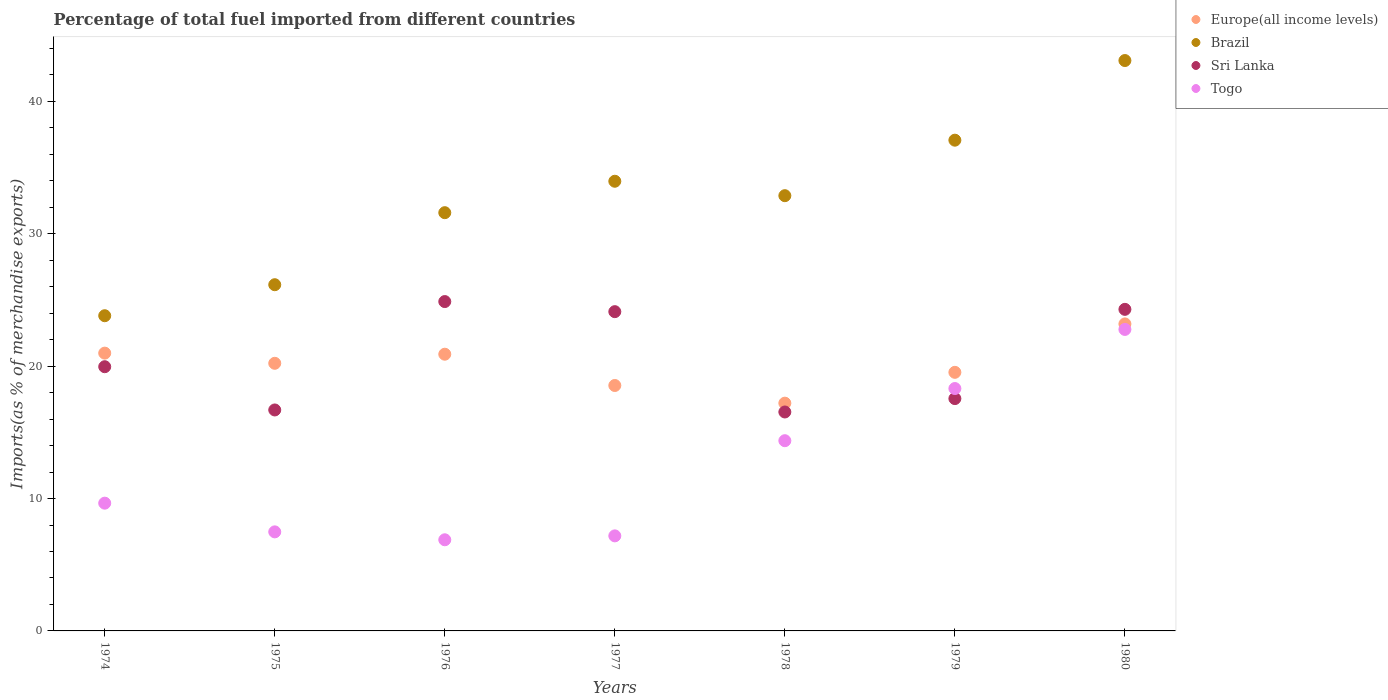What is the percentage of imports to different countries in Togo in 1976?
Offer a very short reply. 6.88. Across all years, what is the maximum percentage of imports to different countries in Sri Lanka?
Offer a terse response. 24.88. Across all years, what is the minimum percentage of imports to different countries in Europe(all income levels)?
Offer a very short reply. 17.2. In which year was the percentage of imports to different countries in Togo minimum?
Keep it short and to the point. 1976. What is the total percentage of imports to different countries in Togo in the graph?
Give a very brief answer. 86.65. What is the difference between the percentage of imports to different countries in Europe(all income levels) in 1978 and that in 1979?
Your response must be concise. -2.33. What is the difference between the percentage of imports to different countries in Sri Lanka in 1975 and the percentage of imports to different countries in Europe(all income levels) in 1977?
Your response must be concise. -1.85. What is the average percentage of imports to different countries in Togo per year?
Your response must be concise. 12.38. In the year 1975, what is the difference between the percentage of imports to different countries in Togo and percentage of imports to different countries in Sri Lanka?
Provide a succinct answer. -9.21. In how many years, is the percentage of imports to different countries in Togo greater than 20 %?
Make the answer very short. 1. What is the ratio of the percentage of imports to different countries in Brazil in 1974 to that in 1978?
Offer a terse response. 0.72. Is the percentage of imports to different countries in Europe(all income levels) in 1978 less than that in 1979?
Your answer should be very brief. Yes. What is the difference between the highest and the second highest percentage of imports to different countries in Europe(all income levels)?
Make the answer very short. 2.21. What is the difference between the highest and the lowest percentage of imports to different countries in Europe(all income levels)?
Offer a terse response. 5.98. In how many years, is the percentage of imports to different countries in Brazil greater than the average percentage of imports to different countries in Brazil taken over all years?
Your response must be concise. 4. Is it the case that in every year, the sum of the percentage of imports to different countries in Europe(all income levels) and percentage of imports to different countries in Sri Lanka  is greater than the percentage of imports to different countries in Brazil?
Keep it short and to the point. Yes. Does the percentage of imports to different countries in Brazil monotonically increase over the years?
Your response must be concise. No. Is the percentage of imports to different countries in Togo strictly greater than the percentage of imports to different countries in Sri Lanka over the years?
Provide a succinct answer. No. Is the percentage of imports to different countries in Europe(all income levels) strictly less than the percentage of imports to different countries in Brazil over the years?
Keep it short and to the point. Yes. Does the graph contain grids?
Offer a terse response. No. How many legend labels are there?
Provide a short and direct response. 4. What is the title of the graph?
Your response must be concise. Percentage of total fuel imported from different countries. Does "Mexico" appear as one of the legend labels in the graph?
Offer a very short reply. No. What is the label or title of the X-axis?
Your answer should be compact. Years. What is the label or title of the Y-axis?
Your answer should be compact. Imports(as % of merchandise exports). What is the Imports(as % of merchandise exports) of Europe(all income levels) in 1974?
Make the answer very short. 20.98. What is the Imports(as % of merchandise exports) in Brazil in 1974?
Give a very brief answer. 23.81. What is the Imports(as % of merchandise exports) in Sri Lanka in 1974?
Provide a short and direct response. 19.96. What is the Imports(as % of merchandise exports) of Togo in 1974?
Your response must be concise. 9.65. What is the Imports(as % of merchandise exports) in Europe(all income levels) in 1975?
Ensure brevity in your answer.  20.22. What is the Imports(as % of merchandise exports) of Brazil in 1975?
Your answer should be compact. 26.15. What is the Imports(as % of merchandise exports) in Sri Lanka in 1975?
Keep it short and to the point. 16.69. What is the Imports(as % of merchandise exports) in Togo in 1975?
Your response must be concise. 7.48. What is the Imports(as % of merchandise exports) of Europe(all income levels) in 1976?
Provide a short and direct response. 20.9. What is the Imports(as % of merchandise exports) of Brazil in 1976?
Offer a very short reply. 31.59. What is the Imports(as % of merchandise exports) in Sri Lanka in 1976?
Your answer should be compact. 24.88. What is the Imports(as % of merchandise exports) in Togo in 1976?
Provide a succinct answer. 6.88. What is the Imports(as % of merchandise exports) in Europe(all income levels) in 1977?
Offer a terse response. 18.54. What is the Imports(as % of merchandise exports) in Brazil in 1977?
Offer a terse response. 33.97. What is the Imports(as % of merchandise exports) of Sri Lanka in 1977?
Give a very brief answer. 24.12. What is the Imports(as % of merchandise exports) in Togo in 1977?
Offer a very short reply. 7.18. What is the Imports(as % of merchandise exports) of Europe(all income levels) in 1978?
Your answer should be very brief. 17.2. What is the Imports(as % of merchandise exports) in Brazil in 1978?
Give a very brief answer. 32.88. What is the Imports(as % of merchandise exports) in Sri Lanka in 1978?
Your answer should be very brief. 16.54. What is the Imports(as % of merchandise exports) in Togo in 1978?
Offer a terse response. 14.37. What is the Imports(as % of merchandise exports) in Europe(all income levels) in 1979?
Offer a terse response. 19.53. What is the Imports(as % of merchandise exports) of Brazil in 1979?
Ensure brevity in your answer.  37.07. What is the Imports(as % of merchandise exports) of Sri Lanka in 1979?
Make the answer very short. 17.55. What is the Imports(as % of merchandise exports) in Togo in 1979?
Give a very brief answer. 18.31. What is the Imports(as % of merchandise exports) of Europe(all income levels) in 1980?
Provide a short and direct response. 23.19. What is the Imports(as % of merchandise exports) in Brazil in 1980?
Offer a terse response. 43.08. What is the Imports(as % of merchandise exports) in Sri Lanka in 1980?
Provide a short and direct response. 24.29. What is the Imports(as % of merchandise exports) of Togo in 1980?
Offer a terse response. 22.77. Across all years, what is the maximum Imports(as % of merchandise exports) in Europe(all income levels)?
Provide a succinct answer. 23.19. Across all years, what is the maximum Imports(as % of merchandise exports) of Brazil?
Provide a short and direct response. 43.08. Across all years, what is the maximum Imports(as % of merchandise exports) in Sri Lanka?
Offer a terse response. 24.88. Across all years, what is the maximum Imports(as % of merchandise exports) in Togo?
Ensure brevity in your answer.  22.77. Across all years, what is the minimum Imports(as % of merchandise exports) in Europe(all income levels)?
Provide a succinct answer. 17.2. Across all years, what is the minimum Imports(as % of merchandise exports) in Brazil?
Make the answer very short. 23.81. Across all years, what is the minimum Imports(as % of merchandise exports) in Sri Lanka?
Make the answer very short. 16.54. Across all years, what is the minimum Imports(as % of merchandise exports) of Togo?
Offer a terse response. 6.88. What is the total Imports(as % of merchandise exports) of Europe(all income levels) in the graph?
Ensure brevity in your answer.  140.57. What is the total Imports(as % of merchandise exports) of Brazil in the graph?
Provide a succinct answer. 228.55. What is the total Imports(as % of merchandise exports) in Sri Lanka in the graph?
Give a very brief answer. 144.02. What is the total Imports(as % of merchandise exports) in Togo in the graph?
Ensure brevity in your answer.  86.65. What is the difference between the Imports(as % of merchandise exports) of Europe(all income levels) in 1974 and that in 1975?
Provide a short and direct response. 0.77. What is the difference between the Imports(as % of merchandise exports) in Brazil in 1974 and that in 1975?
Provide a succinct answer. -2.34. What is the difference between the Imports(as % of merchandise exports) of Sri Lanka in 1974 and that in 1975?
Give a very brief answer. 3.27. What is the difference between the Imports(as % of merchandise exports) in Togo in 1974 and that in 1975?
Offer a very short reply. 2.17. What is the difference between the Imports(as % of merchandise exports) in Europe(all income levels) in 1974 and that in 1976?
Ensure brevity in your answer.  0.08. What is the difference between the Imports(as % of merchandise exports) of Brazil in 1974 and that in 1976?
Give a very brief answer. -7.78. What is the difference between the Imports(as % of merchandise exports) in Sri Lanka in 1974 and that in 1976?
Make the answer very short. -4.92. What is the difference between the Imports(as % of merchandise exports) in Togo in 1974 and that in 1976?
Offer a very short reply. 2.77. What is the difference between the Imports(as % of merchandise exports) in Europe(all income levels) in 1974 and that in 1977?
Make the answer very short. 2.44. What is the difference between the Imports(as % of merchandise exports) of Brazil in 1974 and that in 1977?
Give a very brief answer. -10.16. What is the difference between the Imports(as % of merchandise exports) of Sri Lanka in 1974 and that in 1977?
Your answer should be compact. -4.16. What is the difference between the Imports(as % of merchandise exports) of Togo in 1974 and that in 1977?
Give a very brief answer. 2.47. What is the difference between the Imports(as % of merchandise exports) of Europe(all income levels) in 1974 and that in 1978?
Provide a short and direct response. 3.78. What is the difference between the Imports(as % of merchandise exports) of Brazil in 1974 and that in 1978?
Your answer should be compact. -9.07. What is the difference between the Imports(as % of merchandise exports) of Sri Lanka in 1974 and that in 1978?
Your response must be concise. 3.42. What is the difference between the Imports(as % of merchandise exports) in Togo in 1974 and that in 1978?
Provide a succinct answer. -4.72. What is the difference between the Imports(as % of merchandise exports) of Europe(all income levels) in 1974 and that in 1979?
Your response must be concise. 1.45. What is the difference between the Imports(as % of merchandise exports) in Brazil in 1974 and that in 1979?
Your answer should be very brief. -13.26. What is the difference between the Imports(as % of merchandise exports) of Sri Lanka in 1974 and that in 1979?
Keep it short and to the point. 2.41. What is the difference between the Imports(as % of merchandise exports) in Togo in 1974 and that in 1979?
Keep it short and to the point. -8.66. What is the difference between the Imports(as % of merchandise exports) in Europe(all income levels) in 1974 and that in 1980?
Make the answer very short. -2.21. What is the difference between the Imports(as % of merchandise exports) in Brazil in 1974 and that in 1980?
Offer a very short reply. -19.28. What is the difference between the Imports(as % of merchandise exports) in Sri Lanka in 1974 and that in 1980?
Provide a succinct answer. -4.33. What is the difference between the Imports(as % of merchandise exports) of Togo in 1974 and that in 1980?
Your answer should be compact. -13.12. What is the difference between the Imports(as % of merchandise exports) in Europe(all income levels) in 1975 and that in 1976?
Provide a succinct answer. -0.69. What is the difference between the Imports(as % of merchandise exports) of Brazil in 1975 and that in 1976?
Ensure brevity in your answer.  -5.44. What is the difference between the Imports(as % of merchandise exports) in Sri Lanka in 1975 and that in 1976?
Provide a short and direct response. -8.19. What is the difference between the Imports(as % of merchandise exports) in Togo in 1975 and that in 1976?
Keep it short and to the point. 0.6. What is the difference between the Imports(as % of merchandise exports) of Europe(all income levels) in 1975 and that in 1977?
Your answer should be compact. 1.68. What is the difference between the Imports(as % of merchandise exports) of Brazil in 1975 and that in 1977?
Provide a succinct answer. -7.82. What is the difference between the Imports(as % of merchandise exports) in Sri Lanka in 1975 and that in 1977?
Provide a short and direct response. -7.43. What is the difference between the Imports(as % of merchandise exports) of Togo in 1975 and that in 1977?
Your answer should be very brief. 0.3. What is the difference between the Imports(as % of merchandise exports) of Europe(all income levels) in 1975 and that in 1978?
Make the answer very short. 3.01. What is the difference between the Imports(as % of merchandise exports) in Brazil in 1975 and that in 1978?
Your response must be concise. -6.73. What is the difference between the Imports(as % of merchandise exports) in Sri Lanka in 1975 and that in 1978?
Offer a terse response. 0.15. What is the difference between the Imports(as % of merchandise exports) of Togo in 1975 and that in 1978?
Your answer should be very brief. -6.89. What is the difference between the Imports(as % of merchandise exports) in Europe(all income levels) in 1975 and that in 1979?
Keep it short and to the point. 0.68. What is the difference between the Imports(as % of merchandise exports) in Brazil in 1975 and that in 1979?
Your answer should be compact. -10.92. What is the difference between the Imports(as % of merchandise exports) in Sri Lanka in 1975 and that in 1979?
Ensure brevity in your answer.  -0.86. What is the difference between the Imports(as % of merchandise exports) of Togo in 1975 and that in 1979?
Keep it short and to the point. -10.83. What is the difference between the Imports(as % of merchandise exports) in Europe(all income levels) in 1975 and that in 1980?
Make the answer very short. -2.97. What is the difference between the Imports(as % of merchandise exports) in Brazil in 1975 and that in 1980?
Ensure brevity in your answer.  -16.93. What is the difference between the Imports(as % of merchandise exports) of Sri Lanka in 1975 and that in 1980?
Ensure brevity in your answer.  -7.6. What is the difference between the Imports(as % of merchandise exports) of Togo in 1975 and that in 1980?
Your response must be concise. -15.29. What is the difference between the Imports(as % of merchandise exports) in Europe(all income levels) in 1976 and that in 1977?
Your answer should be very brief. 2.36. What is the difference between the Imports(as % of merchandise exports) of Brazil in 1976 and that in 1977?
Make the answer very short. -2.37. What is the difference between the Imports(as % of merchandise exports) in Sri Lanka in 1976 and that in 1977?
Give a very brief answer. 0.76. What is the difference between the Imports(as % of merchandise exports) in Togo in 1976 and that in 1977?
Provide a short and direct response. -0.3. What is the difference between the Imports(as % of merchandise exports) of Europe(all income levels) in 1976 and that in 1978?
Your response must be concise. 3.7. What is the difference between the Imports(as % of merchandise exports) of Brazil in 1976 and that in 1978?
Your answer should be compact. -1.28. What is the difference between the Imports(as % of merchandise exports) in Sri Lanka in 1976 and that in 1978?
Your answer should be very brief. 8.34. What is the difference between the Imports(as % of merchandise exports) in Togo in 1976 and that in 1978?
Your answer should be compact. -7.48. What is the difference between the Imports(as % of merchandise exports) in Europe(all income levels) in 1976 and that in 1979?
Give a very brief answer. 1.37. What is the difference between the Imports(as % of merchandise exports) of Brazil in 1976 and that in 1979?
Your answer should be compact. -5.48. What is the difference between the Imports(as % of merchandise exports) of Sri Lanka in 1976 and that in 1979?
Your response must be concise. 7.33. What is the difference between the Imports(as % of merchandise exports) of Togo in 1976 and that in 1979?
Your response must be concise. -11.42. What is the difference between the Imports(as % of merchandise exports) in Europe(all income levels) in 1976 and that in 1980?
Make the answer very short. -2.29. What is the difference between the Imports(as % of merchandise exports) in Brazil in 1976 and that in 1980?
Your answer should be compact. -11.49. What is the difference between the Imports(as % of merchandise exports) of Sri Lanka in 1976 and that in 1980?
Offer a very short reply. 0.59. What is the difference between the Imports(as % of merchandise exports) of Togo in 1976 and that in 1980?
Provide a succinct answer. -15.89. What is the difference between the Imports(as % of merchandise exports) of Europe(all income levels) in 1977 and that in 1978?
Give a very brief answer. 1.33. What is the difference between the Imports(as % of merchandise exports) in Brazil in 1977 and that in 1978?
Ensure brevity in your answer.  1.09. What is the difference between the Imports(as % of merchandise exports) in Sri Lanka in 1977 and that in 1978?
Provide a short and direct response. 7.58. What is the difference between the Imports(as % of merchandise exports) of Togo in 1977 and that in 1978?
Your answer should be very brief. -7.19. What is the difference between the Imports(as % of merchandise exports) in Europe(all income levels) in 1977 and that in 1979?
Provide a short and direct response. -0.99. What is the difference between the Imports(as % of merchandise exports) of Brazil in 1977 and that in 1979?
Offer a terse response. -3.1. What is the difference between the Imports(as % of merchandise exports) of Sri Lanka in 1977 and that in 1979?
Keep it short and to the point. 6.57. What is the difference between the Imports(as % of merchandise exports) of Togo in 1977 and that in 1979?
Your answer should be compact. -11.13. What is the difference between the Imports(as % of merchandise exports) in Europe(all income levels) in 1977 and that in 1980?
Give a very brief answer. -4.65. What is the difference between the Imports(as % of merchandise exports) in Brazil in 1977 and that in 1980?
Your response must be concise. -9.12. What is the difference between the Imports(as % of merchandise exports) of Sri Lanka in 1977 and that in 1980?
Ensure brevity in your answer.  -0.17. What is the difference between the Imports(as % of merchandise exports) of Togo in 1977 and that in 1980?
Make the answer very short. -15.59. What is the difference between the Imports(as % of merchandise exports) in Europe(all income levels) in 1978 and that in 1979?
Make the answer very short. -2.33. What is the difference between the Imports(as % of merchandise exports) of Brazil in 1978 and that in 1979?
Provide a succinct answer. -4.19. What is the difference between the Imports(as % of merchandise exports) of Sri Lanka in 1978 and that in 1979?
Keep it short and to the point. -1.01. What is the difference between the Imports(as % of merchandise exports) of Togo in 1978 and that in 1979?
Your response must be concise. -3.94. What is the difference between the Imports(as % of merchandise exports) of Europe(all income levels) in 1978 and that in 1980?
Provide a succinct answer. -5.98. What is the difference between the Imports(as % of merchandise exports) in Brazil in 1978 and that in 1980?
Your answer should be very brief. -10.21. What is the difference between the Imports(as % of merchandise exports) in Sri Lanka in 1978 and that in 1980?
Offer a terse response. -7.75. What is the difference between the Imports(as % of merchandise exports) in Togo in 1978 and that in 1980?
Your answer should be very brief. -8.4. What is the difference between the Imports(as % of merchandise exports) in Europe(all income levels) in 1979 and that in 1980?
Make the answer very short. -3.66. What is the difference between the Imports(as % of merchandise exports) in Brazil in 1979 and that in 1980?
Keep it short and to the point. -6.02. What is the difference between the Imports(as % of merchandise exports) of Sri Lanka in 1979 and that in 1980?
Offer a terse response. -6.74. What is the difference between the Imports(as % of merchandise exports) of Togo in 1979 and that in 1980?
Give a very brief answer. -4.46. What is the difference between the Imports(as % of merchandise exports) in Europe(all income levels) in 1974 and the Imports(as % of merchandise exports) in Brazil in 1975?
Keep it short and to the point. -5.17. What is the difference between the Imports(as % of merchandise exports) of Europe(all income levels) in 1974 and the Imports(as % of merchandise exports) of Sri Lanka in 1975?
Your answer should be very brief. 4.29. What is the difference between the Imports(as % of merchandise exports) of Europe(all income levels) in 1974 and the Imports(as % of merchandise exports) of Togo in 1975?
Ensure brevity in your answer.  13.5. What is the difference between the Imports(as % of merchandise exports) of Brazil in 1974 and the Imports(as % of merchandise exports) of Sri Lanka in 1975?
Your answer should be very brief. 7.12. What is the difference between the Imports(as % of merchandise exports) of Brazil in 1974 and the Imports(as % of merchandise exports) of Togo in 1975?
Your answer should be compact. 16.33. What is the difference between the Imports(as % of merchandise exports) in Sri Lanka in 1974 and the Imports(as % of merchandise exports) in Togo in 1975?
Ensure brevity in your answer.  12.48. What is the difference between the Imports(as % of merchandise exports) of Europe(all income levels) in 1974 and the Imports(as % of merchandise exports) of Brazil in 1976?
Offer a terse response. -10.61. What is the difference between the Imports(as % of merchandise exports) in Europe(all income levels) in 1974 and the Imports(as % of merchandise exports) in Sri Lanka in 1976?
Provide a succinct answer. -3.89. What is the difference between the Imports(as % of merchandise exports) of Europe(all income levels) in 1974 and the Imports(as % of merchandise exports) of Togo in 1976?
Offer a very short reply. 14.1. What is the difference between the Imports(as % of merchandise exports) of Brazil in 1974 and the Imports(as % of merchandise exports) of Sri Lanka in 1976?
Make the answer very short. -1.07. What is the difference between the Imports(as % of merchandise exports) of Brazil in 1974 and the Imports(as % of merchandise exports) of Togo in 1976?
Make the answer very short. 16.92. What is the difference between the Imports(as % of merchandise exports) in Sri Lanka in 1974 and the Imports(as % of merchandise exports) in Togo in 1976?
Your response must be concise. 13.07. What is the difference between the Imports(as % of merchandise exports) in Europe(all income levels) in 1974 and the Imports(as % of merchandise exports) in Brazil in 1977?
Your response must be concise. -12.98. What is the difference between the Imports(as % of merchandise exports) of Europe(all income levels) in 1974 and the Imports(as % of merchandise exports) of Sri Lanka in 1977?
Your answer should be very brief. -3.13. What is the difference between the Imports(as % of merchandise exports) in Europe(all income levels) in 1974 and the Imports(as % of merchandise exports) in Togo in 1977?
Your response must be concise. 13.8. What is the difference between the Imports(as % of merchandise exports) in Brazil in 1974 and the Imports(as % of merchandise exports) in Sri Lanka in 1977?
Give a very brief answer. -0.31. What is the difference between the Imports(as % of merchandise exports) in Brazil in 1974 and the Imports(as % of merchandise exports) in Togo in 1977?
Keep it short and to the point. 16.63. What is the difference between the Imports(as % of merchandise exports) in Sri Lanka in 1974 and the Imports(as % of merchandise exports) in Togo in 1977?
Give a very brief answer. 12.78. What is the difference between the Imports(as % of merchandise exports) of Europe(all income levels) in 1974 and the Imports(as % of merchandise exports) of Brazil in 1978?
Give a very brief answer. -11.89. What is the difference between the Imports(as % of merchandise exports) in Europe(all income levels) in 1974 and the Imports(as % of merchandise exports) in Sri Lanka in 1978?
Your answer should be very brief. 4.45. What is the difference between the Imports(as % of merchandise exports) of Europe(all income levels) in 1974 and the Imports(as % of merchandise exports) of Togo in 1978?
Keep it short and to the point. 6.62. What is the difference between the Imports(as % of merchandise exports) in Brazil in 1974 and the Imports(as % of merchandise exports) in Sri Lanka in 1978?
Provide a succinct answer. 7.27. What is the difference between the Imports(as % of merchandise exports) in Brazil in 1974 and the Imports(as % of merchandise exports) in Togo in 1978?
Offer a very short reply. 9.44. What is the difference between the Imports(as % of merchandise exports) in Sri Lanka in 1974 and the Imports(as % of merchandise exports) in Togo in 1978?
Give a very brief answer. 5.59. What is the difference between the Imports(as % of merchandise exports) in Europe(all income levels) in 1974 and the Imports(as % of merchandise exports) in Brazil in 1979?
Offer a terse response. -16.09. What is the difference between the Imports(as % of merchandise exports) of Europe(all income levels) in 1974 and the Imports(as % of merchandise exports) of Sri Lanka in 1979?
Provide a short and direct response. 3.43. What is the difference between the Imports(as % of merchandise exports) in Europe(all income levels) in 1974 and the Imports(as % of merchandise exports) in Togo in 1979?
Your answer should be compact. 2.67. What is the difference between the Imports(as % of merchandise exports) of Brazil in 1974 and the Imports(as % of merchandise exports) of Sri Lanka in 1979?
Offer a terse response. 6.26. What is the difference between the Imports(as % of merchandise exports) in Brazil in 1974 and the Imports(as % of merchandise exports) in Togo in 1979?
Provide a short and direct response. 5.5. What is the difference between the Imports(as % of merchandise exports) of Sri Lanka in 1974 and the Imports(as % of merchandise exports) of Togo in 1979?
Keep it short and to the point. 1.65. What is the difference between the Imports(as % of merchandise exports) in Europe(all income levels) in 1974 and the Imports(as % of merchandise exports) in Brazil in 1980?
Keep it short and to the point. -22.1. What is the difference between the Imports(as % of merchandise exports) of Europe(all income levels) in 1974 and the Imports(as % of merchandise exports) of Sri Lanka in 1980?
Provide a succinct answer. -3.31. What is the difference between the Imports(as % of merchandise exports) of Europe(all income levels) in 1974 and the Imports(as % of merchandise exports) of Togo in 1980?
Keep it short and to the point. -1.79. What is the difference between the Imports(as % of merchandise exports) of Brazil in 1974 and the Imports(as % of merchandise exports) of Sri Lanka in 1980?
Give a very brief answer. -0.48. What is the difference between the Imports(as % of merchandise exports) in Brazil in 1974 and the Imports(as % of merchandise exports) in Togo in 1980?
Offer a terse response. 1.04. What is the difference between the Imports(as % of merchandise exports) of Sri Lanka in 1974 and the Imports(as % of merchandise exports) of Togo in 1980?
Ensure brevity in your answer.  -2.82. What is the difference between the Imports(as % of merchandise exports) of Europe(all income levels) in 1975 and the Imports(as % of merchandise exports) of Brazil in 1976?
Provide a succinct answer. -11.38. What is the difference between the Imports(as % of merchandise exports) of Europe(all income levels) in 1975 and the Imports(as % of merchandise exports) of Sri Lanka in 1976?
Keep it short and to the point. -4.66. What is the difference between the Imports(as % of merchandise exports) of Europe(all income levels) in 1975 and the Imports(as % of merchandise exports) of Togo in 1976?
Your answer should be very brief. 13.33. What is the difference between the Imports(as % of merchandise exports) in Brazil in 1975 and the Imports(as % of merchandise exports) in Sri Lanka in 1976?
Keep it short and to the point. 1.27. What is the difference between the Imports(as % of merchandise exports) of Brazil in 1975 and the Imports(as % of merchandise exports) of Togo in 1976?
Provide a succinct answer. 19.27. What is the difference between the Imports(as % of merchandise exports) in Sri Lanka in 1975 and the Imports(as % of merchandise exports) in Togo in 1976?
Your response must be concise. 9.81. What is the difference between the Imports(as % of merchandise exports) in Europe(all income levels) in 1975 and the Imports(as % of merchandise exports) in Brazil in 1977?
Provide a succinct answer. -13.75. What is the difference between the Imports(as % of merchandise exports) of Europe(all income levels) in 1975 and the Imports(as % of merchandise exports) of Sri Lanka in 1977?
Your answer should be very brief. -3.9. What is the difference between the Imports(as % of merchandise exports) in Europe(all income levels) in 1975 and the Imports(as % of merchandise exports) in Togo in 1977?
Offer a terse response. 13.04. What is the difference between the Imports(as % of merchandise exports) of Brazil in 1975 and the Imports(as % of merchandise exports) of Sri Lanka in 1977?
Offer a terse response. 2.04. What is the difference between the Imports(as % of merchandise exports) in Brazil in 1975 and the Imports(as % of merchandise exports) in Togo in 1977?
Your response must be concise. 18.97. What is the difference between the Imports(as % of merchandise exports) in Sri Lanka in 1975 and the Imports(as % of merchandise exports) in Togo in 1977?
Your response must be concise. 9.51. What is the difference between the Imports(as % of merchandise exports) in Europe(all income levels) in 1975 and the Imports(as % of merchandise exports) in Brazil in 1978?
Provide a short and direct response. -12.66. What is the difference between the Imports(as % of merchandise exports) in Europe(all income levels) in 1975 and the Imports(as % of merchandise exports) in Sri Lanka in 1978?
Keep it short and to the point. 3.68. What is the difference between the Imports(as % of merchandise exports) in Europe(all income levels) in 1975 and the Imports(as % of merchandise exports) in Togo in 1978?
Your answer should be very brief. 5.85. What is the difference between the Imports(as % of merchandise exports) in Brazil in 1975 and the Imports(as % of merchandise exports) in Sri Lanka in 1978?
Make the answer very short. 9.61. What is the difference between the Imports(as % of merchandise exports) of Brazil in 1975 and the Imports(as % of merchandise exports) of Togo in 1978?
Provide a succinct answer. 11.78. What is the difference between the Imports(as % of merchandise exports) of Sri Lanka in 1975 and the Imports(as % of merchandise exports) of Togo in 1978?
Your answer should be very brief. 2.32. What is the difference between the Imports(as % of merchandise exports) of Europe(all income levels) in 1975 and the Imports(as % of merchandise exports) of Brazil in 1979?
Make the answer very short. -16.85. What is the difference between the Imports(as % of merchandise exports) in Europe(all income levels) in 1975 and the Imports(as % of merchandise exports) in Sri Lanka in 1979?
Offer a terse response. 2.67. What is the difference between the Imports(as % of merchandise exports) of Europe(all income levels) in 1975 and the Imports(as % of merchandise exports) of Togo in 1979?
Provide a succinct answer. 1.91. What is the difference between the Imports(as % of merchandise exports) of Brazil in 1975 and the Imports(as % of merchandise exports) of Sri Lanka in 1979?
Your answer should be very brief. 8.6. What is the difference between the Imports(as % of merchandise exports) of Brazil in 1975 and the Imports(as % of merchandise exports) of Togo in 1979?
Offer a terse response. 7.84. What is the difference between the Imports(as % of merchandise exports) of Sri Lanka in 1975 and the Imports(as % of merchandise exports) of Togo in 1979?
Ensure brevity in your answer.  -1.62. What is the difference between the Imports(as % of merchandise exports) of Europe(all income levels) in 1975 and the Imports(as % of merchandise exports) of Brazil in 1980?
Offer a very short reply. -22.87. What is the difference between the Imports(as % of merchandise exports) of Europe(all income levels) in 1975 and the Imports(as % of merchandise exports) of Sri Lanka in 1980?
Offer a terse response. -4.08. What is the difference between the Imports(as % of merchandise exports) in Europe(all income levels) in 1975 and the Imports(as % of merchandise exports) in Togo in 1980?
Your response must be concise. -2.56. What is the difference between the Imports(as % of merchandise exports) in Brazil in 1975 and the Imports(as % of merchandise exports) in Sri Lanka in 1980?
Provide a short and direct response. 1.86. What is the difference between the Imports(as % of merchandise exports) in Brazil in 1975 and the Imports(as % of merchandise exports) in Togo in 1980?
Your answer should be very brief. 3.38. What is the difference between the Imports(as % of merchandise exports) in Sri Lanka in 1975 and the Imports(as % of merchandise exports) in Togo in 1980?
Your answer should be compact. -6.08. What is the difference between the Imports(as % of merchandise exports) in Europe(all income levels) in 1976 and the Imports(as % of merchandise exports) in Brazil in 1977?
Provide a short and direct response. -13.07. What is the difference between the Imports(as % of merchandise exports) of Europe(all income levels) in 1976 and the Imports(as % of merchandise exports) of Sri Lanka in 1977?
Provide a succinct answer. -3.21. What is the difference between the Imports(as % of merchandise exports) of Europe(all income levels) in 1976 and the Imports(as % of merchandise exports) of Togo in 1977?
Give a very brief answer. 13.72. What is the difference between the Imports(as % of merchandise exports) in Brazil in 1976 and the Imports(as % of merchandise exports) in Sri Lanka in 1977?
Keep it short and to the point. 7.48. What is the difference between the Imports(as % of merchandise exports) of Brazil in 1976 and the Imports(as % of merchandise exports) of Togo in 1977?
Make the answer very short. 24.41. What is the difference between the Imports(as % of merchandise exports) of Sri Lanka in 1976 and the Imports(as % of merchandise exports) of Togo in 1977?
Ensure brevity in your answer.  17.7. What is the difference between the Imports(as % of merchandise exports) of Europe(all income levels) in 1976 and the Imports(as % of merchandise exports) of Brazil in 1978?
Your answer should be compact. -11.98. What is the difference between the Imports(as % of merchandise exports) in Europe(all income levels) in 1976 and the Imports(as % of merchandise exports) in Sri Lanka in 1978?
Provide a succinct answer. 4.36. What is the difference between the Imports(as % of merchandise exports) in Europe(all income levels) in 1976 and the Imports(as % of merchandise exports) in Togo in 1978?
Keep it short and to the point. 6.53. What is the difference between the Imports(as % of merchandise exports) of Brazil in 1976 and the Imports(as % of merchandise exports) of Sri Lanka in 1978?
Keep it short and to the point. 15.05. What is the difference between the Imports(as % of merchandise exports) in Brazil in 1976 and the Imports(as % of merchandise exports) in Togo in 1978?
Make the answer very short. 17.22. What is the difference between the Imports(as % of merchandise exports) of Sri Lanka in 1976 and the Imports(as % of merchandise exports) of Togo in 1978?
Provide a succinct answer. 10.51. What is the difference between the Imports(as % of merchandise exports) of Europe(all income levels) in 1976 and the Imports(as % of merchandise exports) of Brazil in 1979?
Ensure brevity in your answer.  -16.17. What is the difference between the Imports(as % of merchandise exports) of Europe(all income levels) in 1976 and the Imports(as % of merchandise exports) of Sri Lanka in 1979?
Provide a short and direct response. 3.35. What is the difference between the Imports(as % of merchandise exports) in Europe(all income levels) in 1976 and the Imports(as % of merchandise exports) in Togo in 1979?
Provide a succinct answer. 2.59. What is the difference between the Imports(as % of merchandise exports) of Brazil in 1976 and the Imports(as % of merchandise exports) of Sri Lanka in 1979?
Offer a very short reply. 14.04. What is the difference between the Imports(as % of merchandise exports) of Brazil in 1976 and the Imports(as % of merchandise exports) of Togo in 1979?
Your answer should be very brief. 13.28. What is the difference between the Imports(as % of merchandise exports) of Sri Lanka in 1976 and the Imports(as % of merchandise exports) of Togo in 1979?
Ensure brevity in your answer.  6.57. What is the difference between the Imports(as % of merchandise exports) in Europe(all income levels) in 1976 and the Imports(as % of merchandise exports) in Brazil in 1980?
Keep it short and to the point. -22.18. What is the difference between the Imports(as % of merchandise exports) of Europe(all income levels) in 1976 and the Imports(as % of merchandise exports) of Sri Lanka in 1980?
Provide a succinct answer. -3.39. What is the difference between the Imports(as % of merchandise exports) of Europe(all income levels) in 1976 and the Imports(as % of merchandise exports) of Togo in 1980?
Provide a short and direct response. -1.87. What is the difference between the Imports(as % of merchandise exports) of Brazil in 1976 and the Imports(as % of merchandise exports) of Sri Lanka in 1980?
Your answer should be very brief. 7.3. What is the difference between the Imports(as % of merchandise exports) of Brazil in 1976 and the Imports(as % of merchandise exports) of Togo in 1980?
Keep it short and to the point. 8.82. What is the difference between the Imports(as % of merchandise exports) in Sri Lanka in 1976 and the Imports(as % of merchandise exports) in Togo in 1980?
Your answer should be compact. 2.1. What is the difference between the Imports(as % of merchandise exports) in Europe(all income levels) in 1977 and the Imports(as % of merchandise exports) in Brazil in 1978?
Offer a terse response. -14.34. What is the difference between the Imports(as % of merchandise exports) in Europe(all income levels) in 1977 and the Imports(as % of merchandise exports) in Sri Lanka in 1978?
Your answer should be very brief. 2. What is the difference between the Imports(as % of merchandise exports) in Europe(all income levels) in 1977 and the Imports(as % of merchandise exports) in Togo in 1978?
Your answer should be very brief. 4.17. What is the difference between the Imports(as % of merchandise exports) of Brazil in 1977 and the Imports(as % of merchandise exports) of Sri Lanka in 1978?
Your response must be concise. 17.43. What is the difference between the Imports(as % of merchandise exports) in Brazil in 1977 and the Imports(as % of merchandise exports) in Togo in 1978?
Your answer should be very brief. 19.6. What is the difference between the Imports(as % of merchandise exports) of Sri Lanka in 1977 and the Imports(as % of merchandise exports) of Togo in 1978?
Keep it short and to the point. 9.75. What is the difference between the Imports(as % of merchandise exports) of Europe(all income levels) in 1977 and the Imports(as % of merchandise exports) of Brazil in 1979?
Your answer should be compact. -18.53. What is the difference between the Imports(as % of merchandise exports) in Europe(all income levels) in 1977 and the Imports(as % of merchandise exports) in Togo in 1979?
Your answer should be very brief. 0.23. What is the difference between the Imports(as % of merchandise exports) in Brazil in 1977 and the Imports(as % of merchandise exports) in Sri Lanka in 1979?
Ensure brevity in your answer.  16.42. What is the difference between the Imports(as % of merchandise exports) in Brazil in 1977 and the Imports(as % of merchandise exports) in Togo in 1979?
Your answer should be compact. 15.66. What is the difference between the Imports(as % of merchandise exports) of Sri Lanka in 1977 and the Imports(as % of merchandise exports) of Togo in 1979?
Ensure brevity in your answer.  5.81. What is the difference between the Imports(as % of merchandise exports) of Europe(all income levels) in 1977 and the Imports(as % of merchandise exports) of Brazil in 1980?
Give a very brief answer. -24.55. What is the difference between the Imports(as % of merchandise exports) in Europe(all income levels) in 1977 and the Imports(as % of merchandise exports) in Sri Lanka in 1980?
Offer a very short reply. -5.75. What is the difference between the Imports(as % of merchandise exports) of Europe(all income levels) in 1977 and the Imports(as % of merchandise exports) of Togo in 1980?
Keep it short and to the point. -4.23. What is the difference between the Imports(as % of merchandise exports) of Brazil in 1977 and the Imports(as % of merchandise exports) of Sri Lanka in 1980?
Offer a very short reply. 9.68. What is the difference between the Imports(as % of merchandise exports) of Brazil in 1977 and the Imports(as % of merchandise exports) of Togo in 1980?
Your answer should be compact. 11.19. What is the difference between the Imports(as % of merchandise exports) in Sri Lanka in 1977 and the Imports(as % of merchandise exports) in Togo in 1980?
Your answer should be compact. 1.34. What is the difference between the Imports(as % of merchandise exports) of Europe(all income levels) in 1978 and the Imports(as % of merchandise exports) of Brazil in 1979?
Offer a very short reply. -19.86. What is the difference between the Imports(as % of merchandise exports) of Europe(all income levels) in 1978 and the Imports(as % of merchandise exports) of Sri Lanka in 1979?
Ensure brevity in your answer.  -0.35. What is the difference between the Imports(as % of merchandise exports) in Europe(all income levels) in 1978 and the Imports(as % of merchandise exports) in Togo in 1979?
Offer a terse response. -1.1. What is the difference between the Imports(as % of merchandise exports) of Brazil in 1978 and the Imports(as % of merchandise exports) of Sri Lanka in 1979?
Give a very brief answer. 15.33. What is the difference between the Imports(as % of merchandise exports) of Brazil in 1978 and the Imports(as % of merchandise exports) of Togo in 1979?
Offer a very short reply. 14.57. What is the difference between the Imports(as % of merchandise exports) of Sri Lanka in 1978 and the Imports(as % of merchandise exports) of Togo in 1979?
Provide a succinct answer. -1.77. What is the difference between the Imports(as % of merchandise exports) of Europe(all income levels) in 1978 and the Imports(as % of merchandise exports) of Brazil in 1980?
Provide a short and direct response. -25.88. What is the difference between the Imports(as % of merchandise exports) of Europe(all income levels) in 1978 and the Imports(as % of merchandise exports) of Sri Lanka in 1980?
Your response must be concise. -7.09. What is the difference between the Imports(as % of merchandise exports) in Europe(all income levels) in 1978 and the Imports(as % of merchandise exports) in Togo in 1980?
Offer a terse response. -5.57. What is the difference between the Imports(as % of merchandise exports) in Brazil in 1978 and the Imports(as % of merchandise exports) in Sri Lanka in 1980?
Offer a terse response. 8.59. What is the difference between the Imports(as % of merchandise exports) of Brazil in 1978 and the Imports(as % of merchandise exports) of Togo in 1980?
Offer a terse response. 10.1. What is the difference between the Imports(as % of merchandise exports) of Sri Lanka in 1978 and the Imports(as % of merchandise exports) of Togo in 1980?
Provide a succinct answer. -6.24. What is the difference between the Imports(as % of merchandise exports) of Europe(all income levels) in 1979 and the Imports(as % of merchandise exports) of Brazil in 1980?
Provide a short and direct response. -23.55. What is the difference between the Imports(as % of merchandise exports) of Europe(all income levels) in 1979 and the Imports(as % of merchandise exports) of Sri Lanka in 1980?
Ensure brevity in your answer.  -4.76. What is the difference between the Imports(as % of merchandise exports) of Europe(all income levels) in 1979 and the Imports(as % of merchandise exports) of Togo in 1980?
Your response must be concise. -3.24. What is the difference between the Imports(as % of merchandise exports) in Brazil in 1979 and the Imports(as % of merchandise exports) in Sri Lanka in 1980?
Ensure brevity in your answer.  12.78. What is the difference between the Imports(as % of merchandise exports) in Brazil in 1979 and the Imports(as % of merchandise exports) in Togo in 1980?
Make the answer very short. 14.3. What is the difference between the Imports(as % of merchandise exports) of Sri Lanka in 1979 and the Imports(as % of merchandise exports) of Togo in 1980?
Make the answer very short. -5.22. What is the average Imports(as % of merchandise exports) of Europe(all income levels) per year?
Provide a succinct answer. 20.08. What is the average Imports(as % of merchandise exports) of Brazil per year?
Your answer should be very brief. 32.65. What is the average Imports(as % of merchandise exports) in Sri Lanka per year?
Your answer should be very brief. 20.57. What is the average Imports(as % of merchandise exports) in Togo per year?
Your answer should be very brief. 12.38. In the year 1974, what is the difference between the Imports(as % of merchandise exports) in Europe(all income levels) and Imports(as % of merchandise exports) in Brazil?
Give a very brief answer. -2.83. In the year 1974, what is the difference between the Imports(as % of merchandise exports) in Europe(all income levels) and Imports(as % of merchandise exports) in Sri Lanka?
Make the answer very short. 1.03. In the year 1974, what is the difference between the Imports(as % of merchandise exports) in Europe(all income levels) and Imports(as % of merchandise exports) in Togo?
Offer a terse response. 11.33. In the year 1974, what is the difference between the Imports(as % of merchandise exports) of Brazil and Imports(as % of merchandise exports) of Sri Lanka?
Offer a terse response. 3.85. In the year 1974, what is the difference between the Imports(as % of merchandise exports) in Brazil and Imports(as % of merchandise exports) in Togo?
Provide a succinct answer. 14.16. In the year 1974, what is the difference between the Imports(as % of merchandise exports) in Sri Lanka and Imports(as % of merchandise exports) in Togo?
Provide a succinct answer. 10.31. In the year 1975, what is the difference between the Imports(as % of merchandise exports) of Europe(all income levels) and Imports(as % of merchandise exports) of Brazil?
Give a very brief answer. -5.94. In the year 1975, what is the difference between the Imports(as % of merchandise exports) in Europe(all income levels) and Imports(as % of merchandise exports) in Sri Lanka?
Your answer should be compact. 3.52. In the year 1975, what is the difference between the Imports(as % of merchandise exports) of Europe(all income levels) and Imports(as % of merchandise exports) of Togo?
Offer a terse response. 12.73. In the year 1975, what is the difference between the Imports(as % of merchandise exports) of Brazil and Imports(as % of merchandise exports) of Sri Lanka?
Keep it short and to the point. 9.46. In the year 1975, what is the difference between the Imports(as % of merchandise exports) of Brazil and Imports(as % of merchandise exports) of Togo?
Give a very brief answer. 18.67. In the year 1975, what is the difference between the Imports(as % of merchandise exports) of Sri Lanka and Imports(as % of merchandise exports) of Togo?
Make the answer very short. 9.21. In the year 1976, what is the difference between the Imports(as % of merchandise exports) in Europe(all income levels) and Imports(as % of merchandise exports) in Brazil?
Your response must be concise. -10.69. In the year 1976, what is the difference between the Imports(as % of merchandise exports) of Europe(all income levels) and Imports(as % of merchandise exports) of Sri Lanka?
Offer a terse response. -3.98. In the year 1976, what is the difference between the Imports(as % of merchandise exports) in Europe(all income levels) and Imports(as % of merchandise exports) in Togo?
Provide a short and direct response. 14.02. In the year 1976, what is the difference between the Imports(as % of merchandise exports) in Brazil and Imports(as % of merchandise exports) in Sri Lanka?
Make the answer very short. 6.71. In the year 1976, what is the difference between the Imports(as % of merchandise exports) of Brazil and Imports(as % of merchandise exports) of Togo?
Provide a short and direct response. 24.71. In the year 1976, what is the difference between the Imports(as % of merchandise exports) of Sri Lanka and Imports(as % of merchandise exports) of Togo?
Your answer should be compact. 17.99. In the year 1977, what is the difference between the Imports(as % of merchandise exports) in Europe(all income levels) and Imports(as % of merchandise exports) in Brazil?
Offer a terse response. -15.43. In the year 1977, what is the difference between the Imports(as % of merchandise exports) of Europe(all income levels) and Imports(as % of merchandise exports) of Sri Lanka?
Your answer should be very brief. -5.58. In the year 1977, what is the difference between the Imports(as % of merchandise exports) of Europe(all income levels) and Imports(as % of merchandise exports) of Togo?
Provide a succinct answer. 11.36. In the year 1977, what is the difference between the Imports(as % of merchandise exports) in Brazil and Imports(as % of merchandise exports) in Sri Lanka?
Make the answer very short. 9.85. In the year 1977, what is the difference between the Imports(as % of merchandise exports) in Brazil and Imports(as % of merchandise exports) in Togo?
Give a very brief answer. 26.79. In the year 1977, what is the difference between the Imports(as % of merchandise exports) in Sri Lanka and Imports(as % of merchandise exports) in Togo?
Your answer should be compact. 16.94. In the year 1978, what is the difference between the Imports(as % of merchandise exports) of Europe(all income levels) and Imports(as % of merchandise exports) of Brazil?
Your response must be concise. -15.67. In the year 1978, what is the difference between the Imports(as % of merchandise exports) in Europe(all income levels) and Imports(as % of merchandise exports) in Sri Lanka?
Your answer should be compact. 0.67. In the year 1978, what is the difference between the Imports(as % of merchandise exports) of Europe(all income levels) and Imports(as % of merchandise exports) of Togo?
Provide a succinct answer. 2.84. In the year 1978, what is the difference between the Imports(as % of merchandise exports) in Brazil and Imports(as % of merchandise exports) in Sri Lanka?
Your answer should be very brief. 16.34. In the year 1978, what is the difference between the Imports(as % of merchandise exports) of Brazil and Imports(as % of merchandise exports) of Togo?
Keep it short and to the point. 18.51. In the year 1978, what is the difference between the Imports(as % of merchandise exports) of Sri Lanka and Imports(as % of merchandise exports) of Togo?
Provide a short and direct response. 2.17. In the year 1979, what is the difference between the Imports(as % of merchandise exports) of Europe(all income levels) and Imports(as % of merchandise exports) of Brazil?
Keep it short and to the point. -17.54. In the year 1979, what is the difference between the Imports(as % of merchandise exports) of Europe(all income levels) and Imports(as % of merchandise exports) of Sri Lanka?
Your answer should be compact. 1.98. In the year 1979, what is the difference between the Imports(as % of merchandise exports) of Europe(all income levels) and Imports(as % of merchandise exports) of Togo?
Your response must be concise. 1.22. In the year 1979, what is the difference between the Imports(as % of merchandise exports) of Brazil and Imports(as % of merchandise exports) of Sri Lanka?
Offer a terse response. 19.52. In the year 1979, what is the difference between the Imports(as % of merchandise exports) of Brazil and Imports(as % of merchandise exports) of Togo?
Ensure brevity in your answer.  18.76. In the year 1979, what is the difference between the Imports(as % of merchandise exports) in Sri Lanka and Imports(as % of merchandise exports) in Togo?
Make the answer very short. -0.76. In the year 1980, what is the difference between the Imports(as % of merchandise exports) of Europe(all income levels) and Imports(as % of merchandise exports) of Brazil?
Make the answer very short. -19.9. In the year 1980, what is the difference between the Imports(as % of merchandise exports) in Europe(all income levels) and Imports(as % of merchandise exports) in Sri Lanka?
Ensure brevity in your answer.  -1.1. In the year 1980, what is the difference between the Imports(as % of merchandise exports) in Europe(all income levels) and Imports(as % of merchandise exports) in Togo?
Make the answer very short. 0.42. In the year 1980, what is the difference between the Imports(as % of merchandise exports) in Brazil and Imports(as % of merchandise exports) in Sri Lanka?
Give a very brief answer. 18.79. In the year 1980, what is the difference between the Imports(as % of merchandise exports) in Brazil and Imports(as % of merchandise exports) in Togo?
Ensure brevity in your answer.  20.31. In the year 1980, what is the difference between the Imports(as % of merchandise exports) of Sri Lanka and Imports(as % of merchandise exports) of Togo?
Offer a very short reply. 1.52. What is the ratio of the Imports(as % of merchandise exports) of Europe(all income levels) in 1974 to that in 1975?
Offer a terse response. 1.04. What is the ratio of the Imports(as % of merchandise exports) in Brazil in 1974 to that in 1975?
Ensure brevity in your answer.  0.91. What is the ratio of the Imports(as % of merchandise exports) of Sri Lanka in 1974 to that in 1975?
Offer a very short reply. 1.2. What is the ratio of the Imports(as % of merchandise exports) of Togo in 1974 to that in 1975?
Give a very brief answer. 1.29. What is the ratio of the Imports(as % of merchandise exports) in Europe(all income levels) in 1974 to that in 1976?
Keep it short and to the point. 1. What is the ratio of the Imports(as % of merchandise exports) in Brazil in 1974 to that in 1976?
Keep it short and to the point. 0.75. What is the ratio of the Imports(as % of merchandise exports) in Sri Lanka in 1974 to that in 1976?
Ensure brevity in your answer.  0.8. What is the ratio of the Imports(as % of merchandise exports) in Togo in 1974 to that in 1976?
Make the answer very short. 1.4. What is the ratio of the Imports(as % of merchandise exports) in Europe(all income levels) in 1974 to that in 1977?
Your answer should be compact. 1.13. What is the ratio of the Imports(as % of merchandise exports) in Brazil in 1974 to that in 1977?
Offer a terse response. 0.7. What is the ratio of the Imports(as % of merchandise exports) in Sri Lanka in 1974 to that in 1977?
Your answer should be very brief. 0.83. What is the ratio of the Imports(as % of merchandise exports) of Togo in 1974 to that in 1977?
Offer a very short reply. 1.34. What is the ratio of the Imports(as % of merchandise exports) of Europe(all income levels) in 1974 to that in 1978?
Make the answer very short. 1.22. What is the ratio of the Imports(as % of merchandise exports) in Brazil in 1974 to that in 1978?
Offer a very short reply. 0.72. What is the ratio of the Imports(as % of merchandise exports) of Sri Lanka in 1974 to that in 1978?
Your answer should be very brief. 1.21. What is the ratio of the Imports(as % of merchandise exports) of Togo in 1974 to that in 1978?
Give a very brief answer. 0.67. What is the ratio of the Imports(as % of merchandise exports) in Europe(all income levels) in 1974 to that in 1979?
Your response must be concise. 1.07. What is the ratio of the Imports(as % of merchandise exports) in Brazil in 1974 to that in 1979?
Ensure brevity in your answer.  0.64. What is the ratio of the Imports(as % of merchandise exports) in Sri Lanka in 1974 to that in 1979?
Give a very brief answer. 1.14. What is the ratio of the Imports(as % of merchandise exports) in Togo in 1974 to that in 1979?
Offer a terse response. 0.53. What is the ratio of the Imports(as % of merchandise exports) in Europe(all income levels) in 1974 to that in 1980?
Offer a very short reply. 0.9. What is the ratio of the Imports(as % of merchandise exports) of Brazil in 1974 to that in 1980?
Offer a terse response. 0.55. What is the ratio of the Imports(as % of merchandise exports) in Sri Lanka in 1974 to that in 1980?
Make the answer very short. 0.82. What is the ratio of the Imports(as % of merchandise exports) in Togo in 1974 to that in 1980?
Your answer should be compact. 0.42. What is the ratio of the Imports(as % of merchandise exports) of Europe(all income levels) in 1975 to that in 1976?
Make the answer very short. 0.97. What is the ratio of the Imports(as % of merchandise exports) in Brazil in 1975 to that in 1976?
Ensure brevity in your answer.  0.83. What is the ratio of the Imports(as % of merchandise exports) in Sri Lanka in 1975 to that in 1976?
Make the answer very short. 0.67. What is the ratio of the Imports(as % of merchandise exports) of Togo in 1975 to that in 1976?
Your answer should be compact. 1.09. What is the ratio of the Imports(as % of merchandise exports) in Europe(all income levels) in 1975 to that in 1977?
Ensure brevity in your answer.  1.09. What is the ratio of the Imports(as % of merchandise exports) of Brazil in 1975 to that in 1977?
Offer a terse response. 0.77. What is the ratio of the Imports(as % of merchandise exports) of Sri Lanka in 1975 to that in 1977?
Keep it short and to the point. 0.69. What is the ratio of the Imports(as % of merchandise exports) of Togo in 1975 to that in 1977?
Provide a short and direct response. 1.04. What is the ratio of the Imports(as % of merchandise exports) in Europe(all income levels) in 1975 to that in 1978?
Your response must be concise. 1.18. What is the ratio of the Imports(as % of merchandise exports) in Brazil in 1975 to that in 1978?
Your answer should be very brief. 0.8. What is the ratio of the Imports(as % of merchandise exports) in Sri Lanka in 1975 to that in 1978?
Ensure brevity in your answer.  1.01. What is the ratio of the Imports(as % of merchandise exports) in Togo in 1975 to that in 1978?
Offer a very short reply. 0.52. What is the ratio of the Imports(as % of merchandise exports) in Europe(all income levels) in 1975 to that in 1979?
Your answer should be very brief. 1.03. What is the ratio of the Imports(as % of merchandise exports) in Brazil in 1975 to that in 1979?
Offer a very short reply. 0.71. What is the ratio of the Imports(as % of merchandise exports) of Sri Lanka in 1975 to that in 1979?
Ensure brevity in your answer.  0.95. What is the ratio of the Imports(as % of merchandise exports) in Togo in 1975 to that in 1979?
Your response must be concise. 0.41. What is the ratio of the Imports(as % of merchandise exports) of Europe(all income levels) in 1975 to that in 1980?
Offer a terse response. 0.87. What is the ratio of the Imports(as % of merchandise exports) in Brazil in 1975 to that in 1980?
Your response must be concise. 0.61. What is the ratio of the Imports(as % of merchandise exports) of Sri Lanka in 1975 to that in 1980?
Keep it short and to the point. 0.69. What is the ratio of the Imports(as % of merchandise exports) in Togo in 1975 to that in 1980?
Your answer should be compact. 0.33. What is the ratio of the Imports(as % of merchandise exports) of Europe(all income levels) in 1976 to that in 1977?
Ensure brevity in your answer.  1.13. What is the ratio of the Imports(as % of merchandise exports) of Brazil in 1976 to that in 1977?
Give a very brief answer. 0.93. What is the ratio of the Imports(as % of merchandise exports) in Sri Lanka in 1976 to that in 1977?
Offer a very short reply. 1.03. What is the ratio of the Imports(as % of merchandise exports) in Togo in 1976 to that in 1977?
Ensure brevity in your answer.  0.96. What is the ratio of the Imports(as % of merchandise exports) of Europe(all income levels) in 1976 to that in 1978?
Keep it short and to the point. 1.21. What is the ratio of the Imports(as % of merchandise exports) of Brazil in 1976 to that in 1978?
Your response must be concise. 0.96. What is the ratio of the Imports(as % of merchandise exports) in Sri Lanka in 1976 to that in 1978?
Give a very brief answer. 1.5. What is the ratio of the Imports(as % of merchandise exports) in Togo in 1976 to that in 1978?
Provide a succinct answer. 0.48. What is the ratio of the Imports(as % of merchandise exports) of Europe(all income levels) in 1976 to that in 1979?
Your answer should be very brief. 1.07. What is the ratio of the Imports(as % of merchandise exports) in Brazil in 1976 to that in 1979?
Ensure brevity in your answer.  0.85. What is the ratio of the Imports(as % of merchandise exports) of Sri Lanka in 1976 to that in 1979?
Provide a short and direct response. 1.42. What is the ratio of the Imports(as % of merchandise exports) in Togo in 1976 to that in 1979?
Make the answer very short. 0.38. What is the ratio of the Imports(as % of merchandise exports) of Europe(all income levels) in 1976 to that in 1980?
Your response must be concise. 0.9. What is the ratio of the Imports(as % of merchandise exports) of Brazil in 1976 to that in 1980?
Your answer should be very brief. 0.73. What is the ratio of the Imports(as % of merchandise exports) of Sri Lanka in 1976 to that in 1980?
Your response must be concise. 1.02. What is the ratio of the Imports(as % of merchandise exports) of Togo in 1976 to that in 1980?
Your answer should be compact. 0.3. What is the ratio of the Imports(as % of merchandise exports) in Europe(all income levels) in 1977 to that in 1978?
Offer a very short reply. 1.08. What is the ratio of the Imports(as % of merchandise exports) of Brazil in 1977 to that in 1978?
Give a very brief answer. 1.03. What is the ratio of the Imports(as % of merchandise exports) of Sri Lanka in 1977 to that in 1978?
Give a very brief answer. 1.46. What is the ratio of the Imports(as % of merchandise exports) of Togo in 1977 to that in 1978?
Your answer should be compact. 0.5. What is the ratio of the Imports(as % of merchandise exports) of Europe(all income levels) in 1977 to that in 1979?
Your answer should be compact. 0.95. What is the ratio of the Imports(as % of merchandise exports) in Brazil in 1977 to that in 1979?
Your answer should be compact. 0.92. What is the ratio of the Imports(as % of merchandise exports) in Sri Lanka in 1977 to that in 1979?
Make the answer very short. 1.37. What is the ratio of the Imports(as % of merchandise exports) in Togo in 1977 to that in 1979?
Make the answer very short. 0.39. What is the ratio of the Imports(as % of merchandise exports) of Europe(all income levels) in 1977 to that in 1980?
Give a very brief answer. 0.8. What is the ratio of the Imports(as % of merchandise exports) of Brazil in 1977 to that in 1980?
Offer a terse response. 0.79. What is the ratio of the Imports(as % of merchandise exports) in Sri Lanka in 1977 to that in 1980?
Your response must be concise. 0.99. What is the ratio of the Imports(as % of merchandise exports) in Togo in 1977 to that in 1980?
Provide a short and direct response. 0.32. What is the ratio of the Imports(as % of merchandise exports) of Europe(all income levels) in 1978 to that in 1979?
Your answer should be very brief. 0.88. What is the ratio of the Imports(as % of merchandise exports) of Brazil in 1978 to that in 1979?
Ensure brevity in your answer.  0.89. What is the ratio of the Imports(as % of merchandise exports) of Sri Lanka in 1978 to that in 1979?
Your answer should be very brief. 0.94. What is the ratio of the Imports(as % of merchandise exports) in Togo in 1978 to that in 1979?
Provide a succinct answer. 0.78. What is the ratio of the Imports(as % of merchandise exports) of Europe(all income levels) in 1978 to that in 1980?
Your response must be concise. 0.74. What is the ratio of the Imports(as % of merchandise exports) of Brazil in 1978 to that in 1980?
Your response must be concise. 0.76. What is the ratio of the Imports(as % of merchandise exports) in Sri Lanka in 1978 to that in 1980?
Give a very brief answer. 0.68. What is the ratio of the Imports(as % of merchandise exports) of Togo in 1978 to that in 1980?
Offer a very short reply. 0.63. What is the ratio of the Imports(as % of merchandise exports) of Europe(all income levels) in 1979 to that in 1980?
Provide a short and direct response. 0.84. What is the ratio of the Imports(as % of merchandise exports) in Brazil in 1979 to that in 1980?
Your answer should be compact. 0.86. What is the ratio of the Imports(as % of merchandise exports) in Sri Lanka in 1979 to that in 1980?
Provide a short and direct response. 0.72. What is the ratio of the Imports(as % of merchandise exports) in Togo in 1979 to that in 1980?
Your response must be concise. 0.8. What is the difference between the highest and the second highest Imports(as % of merchandise exports) in Europe(all income levels)?
Provide a succinct answer. 2.21. What is the difference between the highest and the second highest Imports(as % of merchandise exports) of Brazil?
Make the answer very short. 6.02. What is the difference between the highest and the second highest Imports(as % of merchandise exports) of Sri Lanka?
Give a very brief answer. 0.59. What is the difference between the highest and the second highest Imports(as % of merchandise exports) in Togo?
Offer a terse response. 4.46. What is the difference between the highest and the lowest Imports(as % of merchandise exports) in Europe(all income levels)?
Keep it short and to the point. 5.98. What is the difference between the highest and the lowest Imports(as % of merchandise exports) of Brazil?
Ensure brevity in your answer.  19.28. What is the difference between the highest and the lowest Imports(as % of merchandise exports) in Sri Lanka?
Provide a short and direct response. 8.34. What is the difference between the highest and the lowest Imports(as % of merchandise exports) in Togo?
Provide a succinct answer. 15.89. 